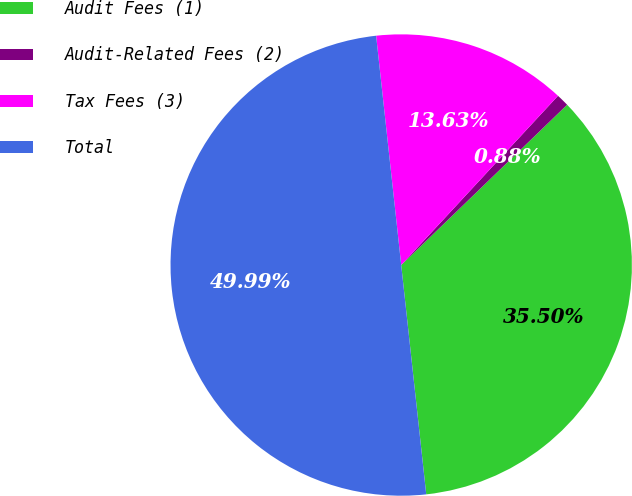Convert chart. <chart><loc_0><loc_0><loc_500><loc_500><pie_chart><fcel>Audit Fees (1)<fcel>Audit-Related Fees (2)<fcel>Tax Fees (3)<fcel>Total<nl><fcel>35.5%<fcel>0.88%<fcel>13.63%<fcel>50.0%<nl></chart> 